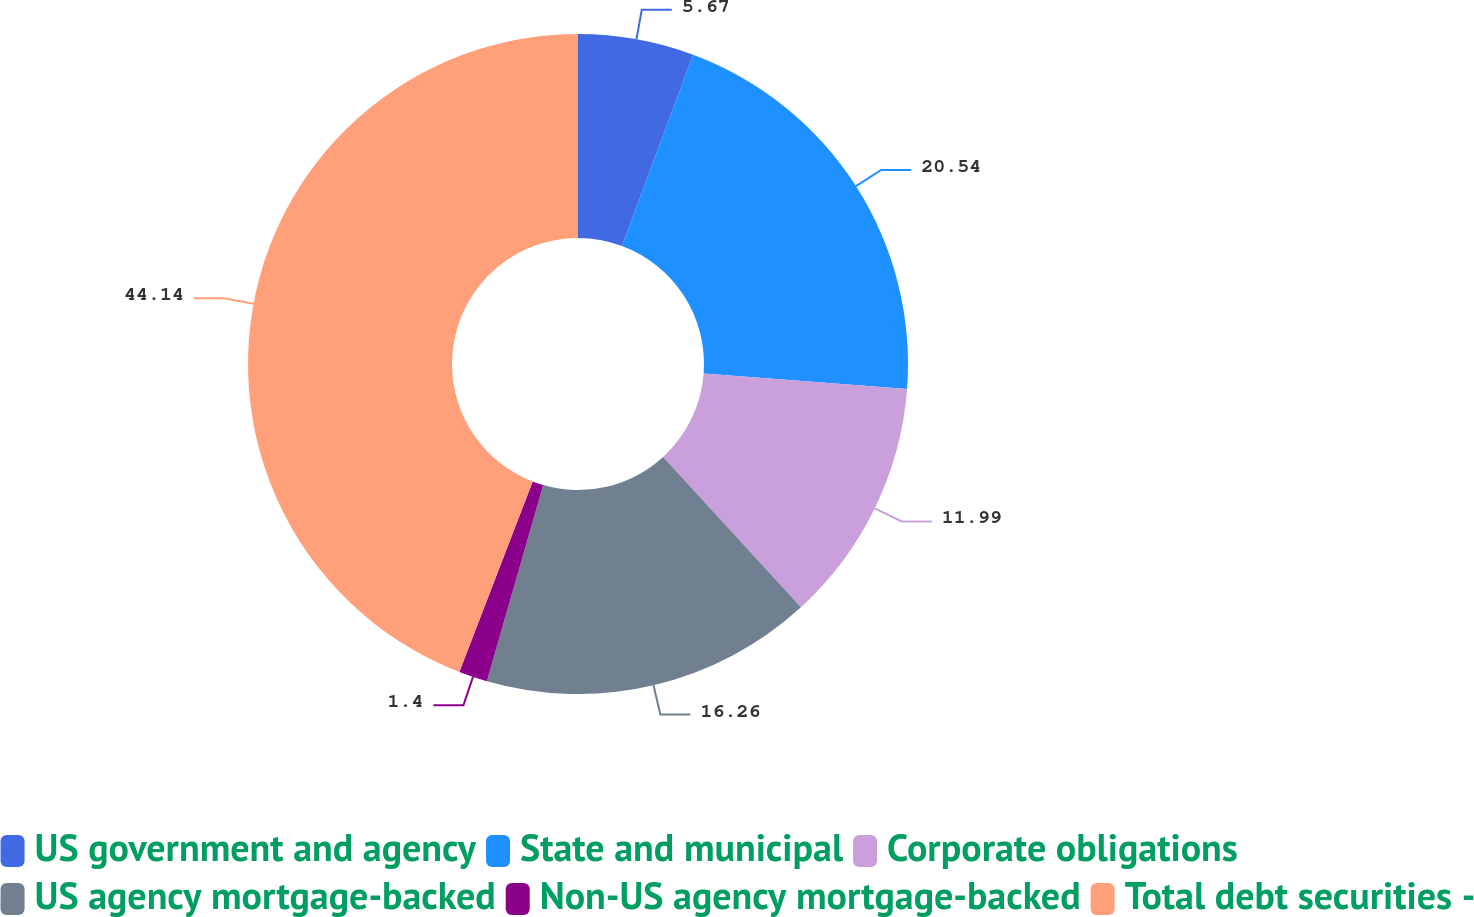Convert chart. <chart><loc_0><loc_0><loc_500><loc_500><pie_chart><fcel>US government and agency<fcel>State and municipal<fcel>Corporate obligations<fcel>US agency mortgage-backed<fcel>Non-US agency mortgage-backed<fcel>Total debt securities -<nl><fcel>5.67%<fcel>20.54%<fcel>11.99%<fcel>16.26%<fcel>1.4%<fcel>44.15%<nl></chart> 